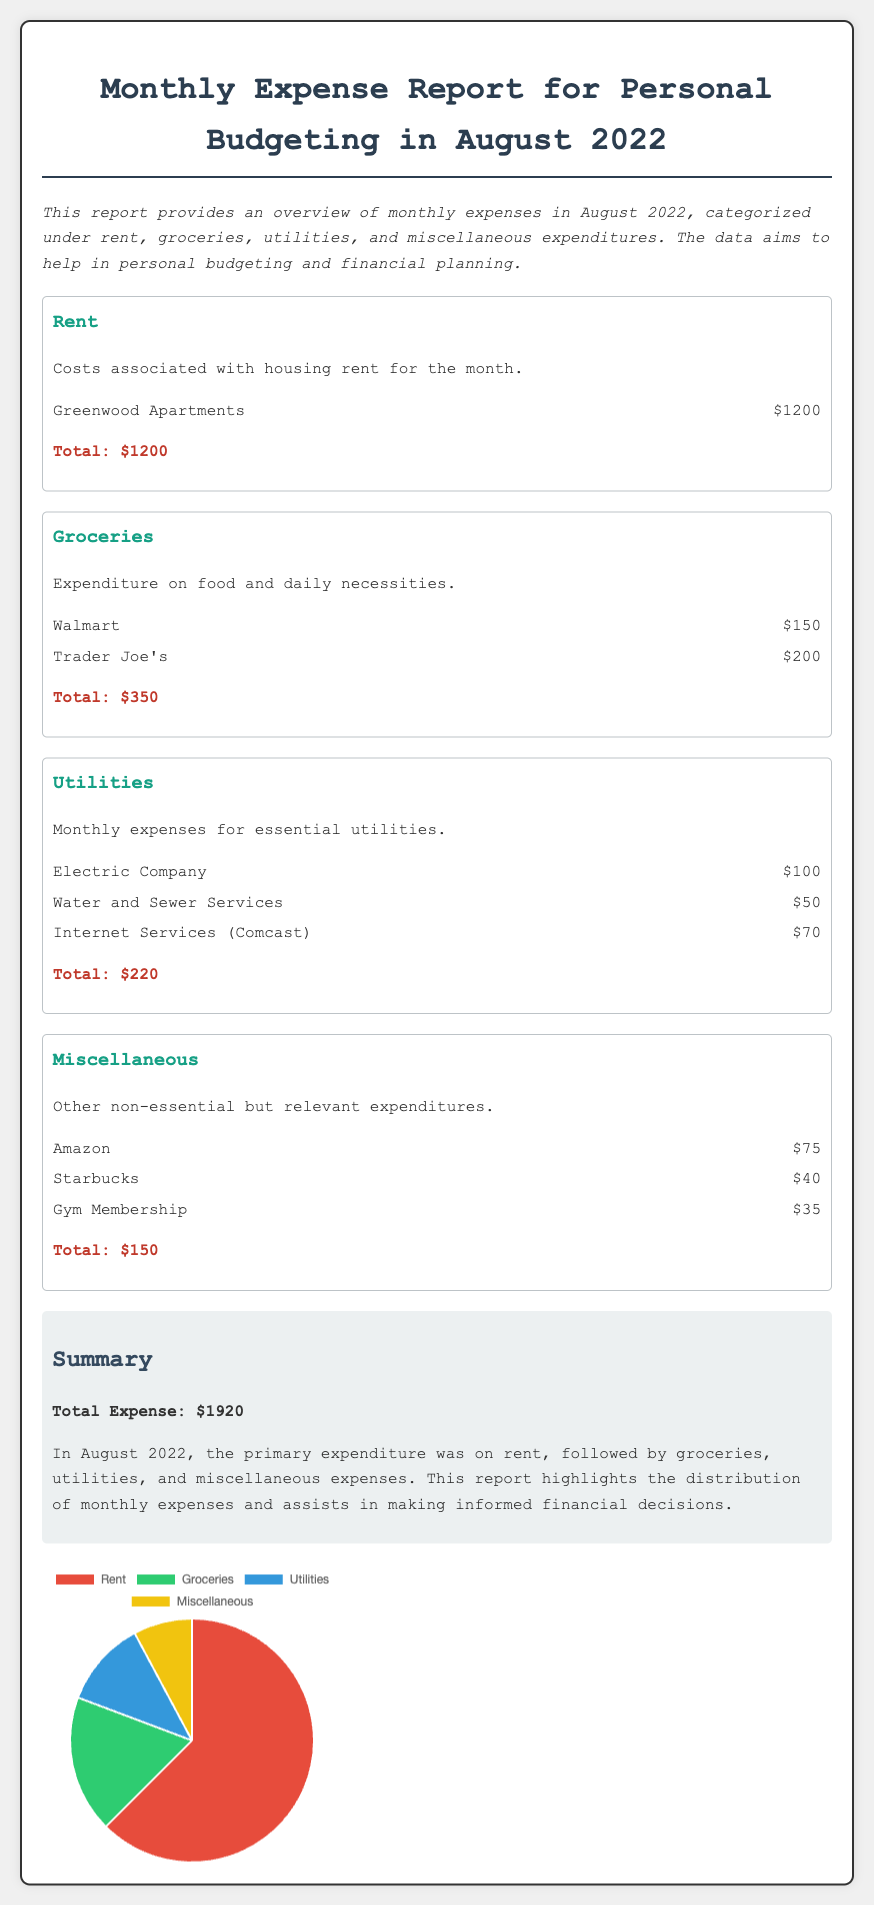What is the total expense for August 2022? The total expense is stated in the summary section of the document as the sum of all categorized expenditures.
Answer: $1920 How much was spent on rent? The document specifies the amount spent on rent in the rent category.
Answer: $1200 Which grocery store had the highest expenditure? The details within the groceries category provide specific store expenditures, from which the highest can be identified.
Answer: Trader Joe's What is the total amount spent on utilities? The total for utilities is provided at the end of the utilities section in the document.
Answer: $220 How many categories of expenditure are listed in the report? The report lists four different categories of expenditures.
Answer: 4 Which category has the lowest total expenditure? By comparing the totals for each category, the one with the lowest total can be determined.
Answer: Miscellaneous What percentage of the total expense is spent on groceries? The percentage can be calculated from the grocery total compared to total expenses stated in the summary.
Answer: 18.2% What type of chart is used to visualize the expense distribution? The chart type is mentioned in the script section, indicating the kind of visual representation employed.
Answer: Pie What color represents the utilities category in the chart? The background colors for each category are specifically mentioned within the dataset of the chart.
Answer: #3498db 